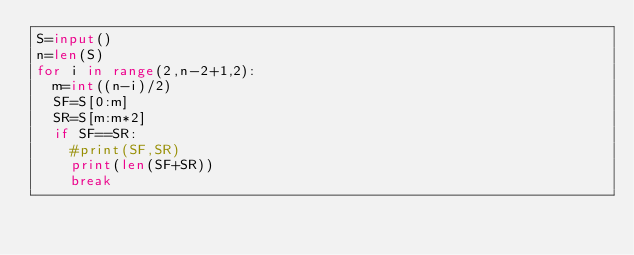Convert code to text. <code><loc_0><loc_0><loc_500><loc_500><_Python_>S=input()
n=len(S)
for i in range(2,n-2+1,2):
  m=int((n-i)/2)
  SF=S[0:m]
  SR=S[m:m*2]
  if SF==SR:
    #print(SF,SR)
    print(len(SF+SR))
    break</code> 